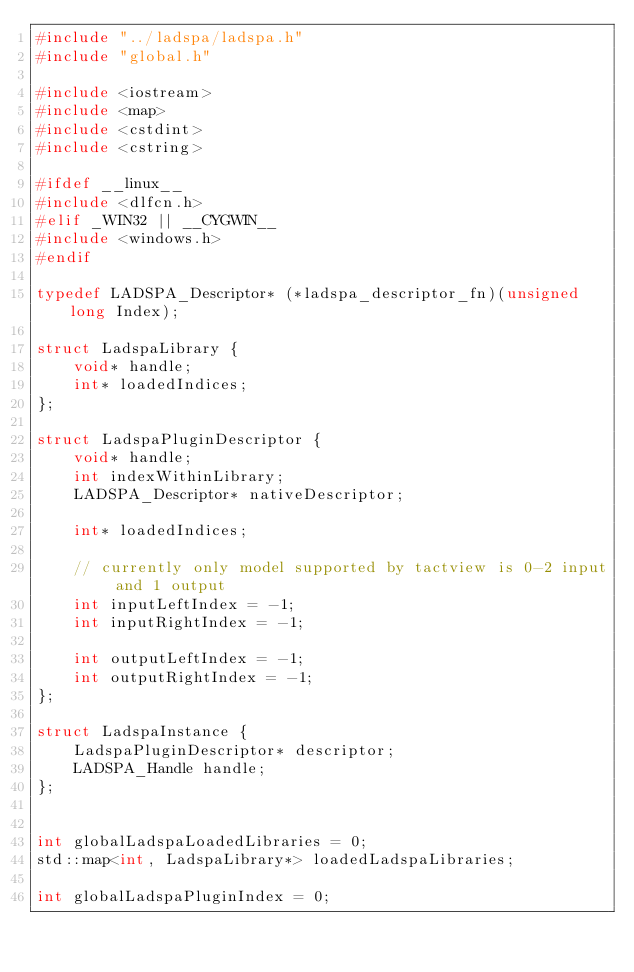<code> <loc_0><loc_0><loc_500><loc_500><_C++_>#include "../ladspa/ladspa.h"
#include "global.h"

#include <iostream>
#include <map>
#include <cstdint>
#include <cstring>

#ifdef __linux__ 
#include <dlfcn.h>
#elif _WIN32 || __CYGWIN__
#include <windows.h>
#endif

typedef LADSPA_Descriptor* (*ladspa_descriptor_fn)(unsigned long Index);

struct LadspaLibrary {
    void* handle;
    int* loadedIndices;
};

struct LadspaPluginDescriptor {
    void* handle;
    int indexWithinLibrary;
    LADSPA_Descriptor* nativeDescriptor;

    int* loadedIndices;

    // currently only model supported by tactview is 0-2 input and 1 output
    int inputLeftIndex = -1;
    int inputRightIndex = -1;

    int outputLeftIndex = -1;
    int outputRightIndex = -1;
};

struct LadspaInstance {
    LadspaPluginDescriptor* descriptor;
    LADSPA_Handle handle;
};


int globalLadspaLoadedLibraries = 0;
std::map<int, LadspaLibrary*> loadedLadspaLibraries;

int globalLadspaPluginIndex = 0;</code> 